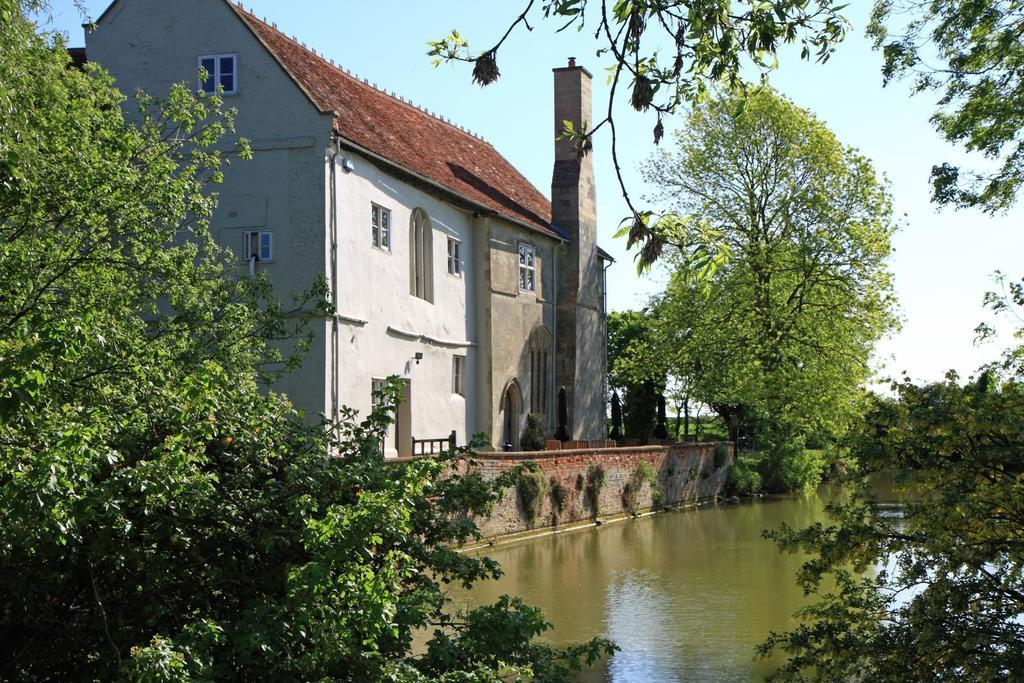What structure is located on the left side of the image? There is a house on the left side of the image. What can be seen in the image besides the house? There appears to be a tower, a river at the bottom, trees, and the sky visible at the top of the image. Can you tell me how many ladybugs are on the trees in the image? There are no ladybugs present in the image; it features a house, a tower, a river, trees, and the sky. What is the son of the house owner doing in the image? There is no information about a son or any person's activities in the image. 